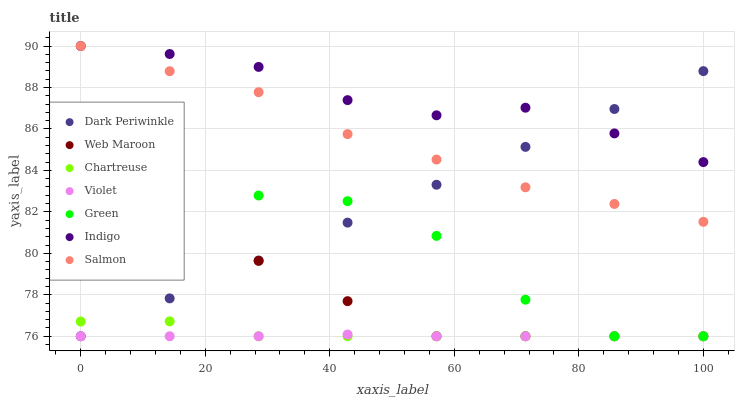Does Violet have the minimum area under the curve?
Answer yes or no. Yes. Does Indigo have the maximum area under the curve?
Answer yes or no. Yes. Does Salmon have the minimum area under the curve?
Answer yes or no. No. Does Salmon have the maximum area under the curve?
Answer yes or no. No. Is Dark Periwinkle the smoothest?
Answer yes or no. Yes. Is Green the roughest?
Answer yes or no. Yes. Is Salmon the smoothest?
Answer yes or no. No. Is Salmon the roughest?
Answer yes or no. No. Does Web Maroon have the lowest value?
Answer yes or no. Yes. Does Salmon have the lowest value?
Answer yes or no. No. Does Salmon have the highest value?
Answer yes or no. Yes. Does Web Maroon have the highest value?
Answer yes or no. No. Is Violet less than Indigo?
Answer yes or no. Yes. Is Indigo greater than Green?
Answer yes or no. Yes. Does Chartreuse intersect Violet?
Answer yes or no. Yes. Is Chartreuse less than Violet?
Answer yes or no. No. Is Chartreuse greater than Violet?
Answer yes or no. No. Does Violet intersect Indigo?
Answer yes or no. No. 